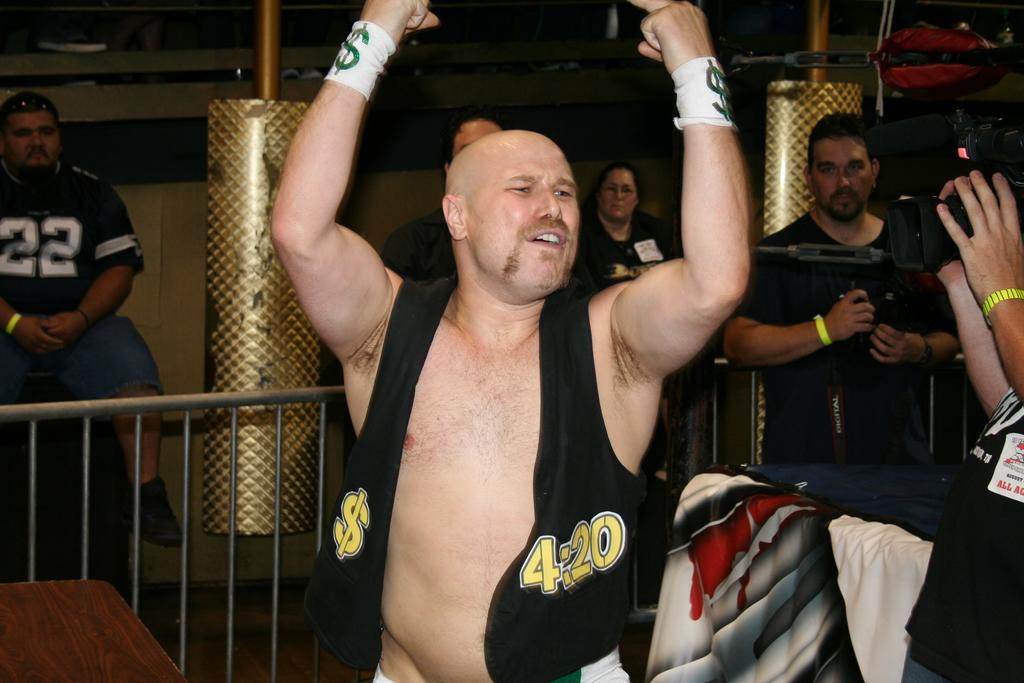<image>
Render a clear and concise summary of the photo. A wrestler wearing a waistcoat with a $ sign on it and the numbers 420 enters the hall. 